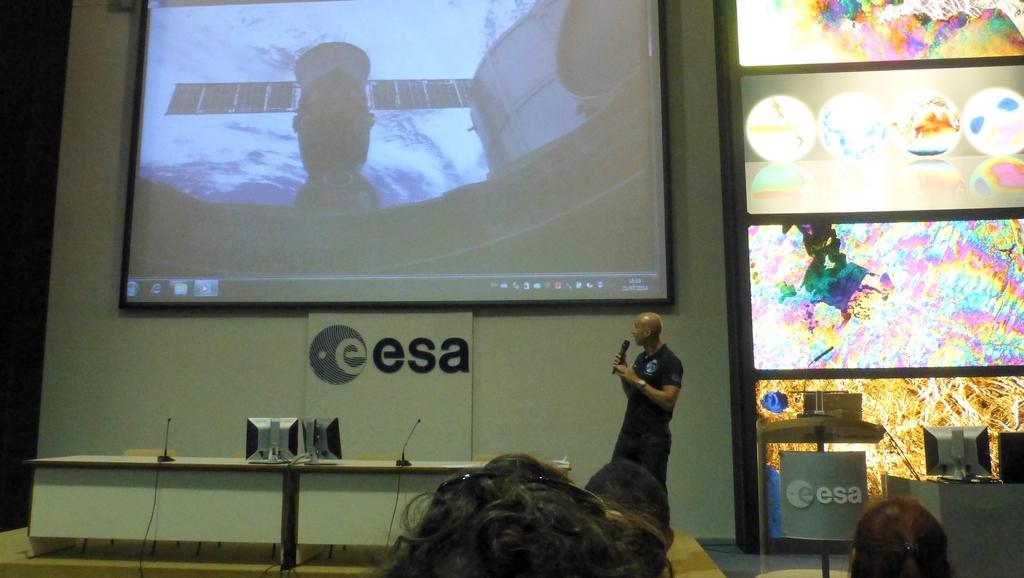Could you give a brief overview of what you see in this image? In this image we can see heads of people, here we can see a person wearing black T-shirt is holding a mic and standing, here we can see monitors and mics are kept on the table, also we can see chairs. In the background, we can see the projector screen to the wall on which we can see something is displayed. Here we can see monitors and a few more objects. 